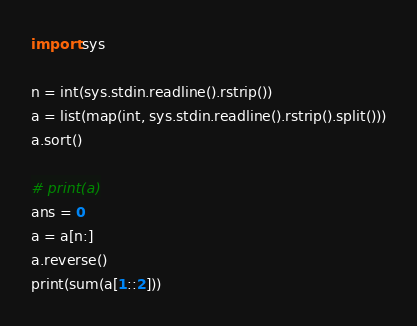Convert code to text. <code><loc_0><loc_0><loc_500><loc_500><_Python_>import sys

n = int(sys.stdin.readline().rstrip())
a = list(map(int, sys.stdin.readline().rstrip().split()))
a.sort()

# print(a)
ans = 0
a = a[n:]
a.reverse()
print(sum(a[1::2]))</code> 